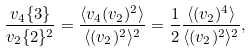Convert formula to latex. <formula><loc_0><loc_0><loc_500><loc_500>\frac { v _ { 4 } \{ 3 \} } { v _ { 2 } \{ 2 \} ^ { 2 } } = \frac { \langle v _ { 4 } ( v _ { 2 } ) ^ { 2 } \rangle } { \langle ( v _ { 2 } ) ^ { 2 } \rangle ^ { 2 } } = \frac { 1 } { 2 } \frac { \langle ( v _ { 2 } ) ^ { 4 } \rangle } { \langle ( v _ { 2 } ) ^ { 2 } \rangle ^ { 2 } } ,</formula> 